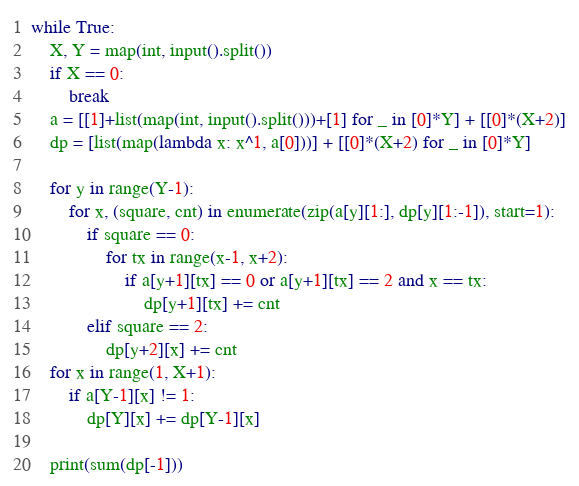<code> <loc_0><loc_0><loc_500><loc_500><_Python_>while True:
    X, Y = map(int, input().split())
    if X == 0:
        break
    a = [[1]+list(map(int, input().split()))+[1] for _ in [0]*Y] + [[0]*(X+2)]
    dp = [list(map(lambda x: x^1, a[0]))] + [[0]*(X+2) for _ in [0]*Y]

    for y in range(Y-1):
        for x, (square, cnt) in enumerate(zip(a[y][1:], dp[y][1:-1]), start=1):
            if square == 0:
                for tx in range(x-1, x+2):
                    if a[y+1][tx] == 0 or a[y+1][tx] == 2 and x == tx:
                        dp[y+1][tx] += cnt
            elif square == 2:
                dp[y+2][x] += cnt
    for x in range(1, X+1):
        if a[Y-1][x] != 1:
            dp[Y][x] += dp[Y-1][x]

    print(sum(dp[-1]))
</code> 